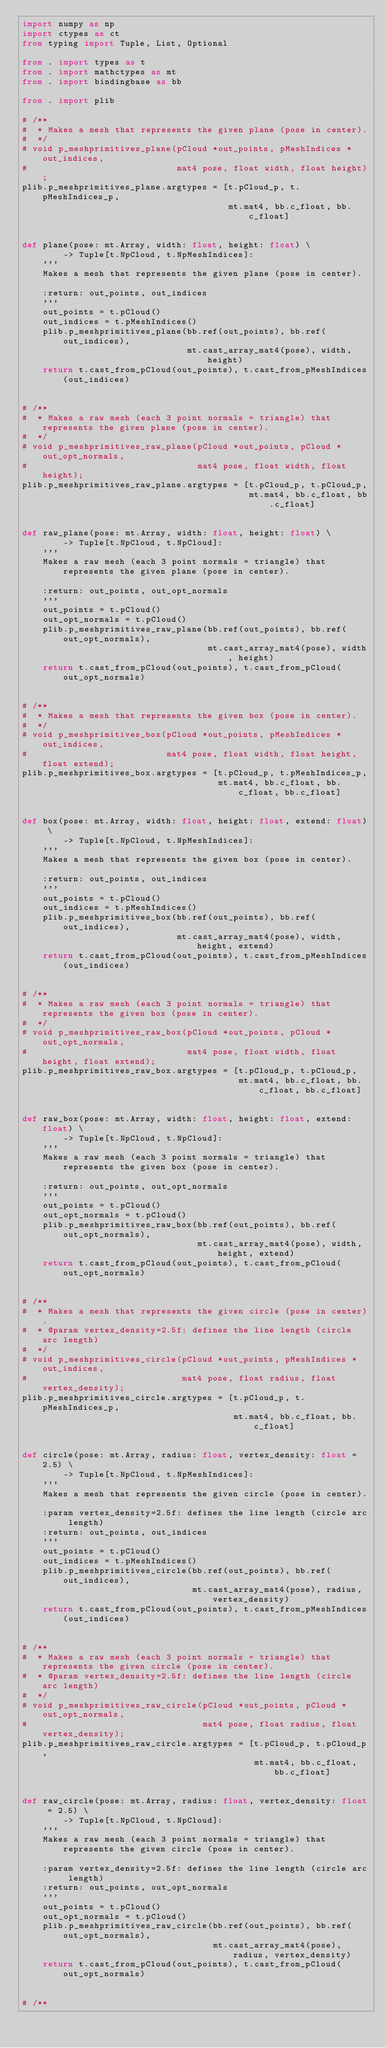<code> <loc_0><loc_0><loc_500><loc_500><_Python_>import numpy as np
import ctypes as ct
from typing import Tuple, List, Optional

from . import types as t
from . import mathctypes as mt
from . import bindingbase as bb

from . import plib

# /**
#  * Makes a mesh that represents the given plane (pose in center).
#  */
# void p_meshprimitives_plane(pCloud *out_points, pMeshIndices *out_indices,
#                             mat4 pose, float width, float height);
plib.p_meshprimitives_plane.argtypes = [t.pCloud_p, t.pMeshIndices_p,
                                        mt.mat4, bb.c_float, bb.c_float]


def plane(pose: mt.Array, width: float, height: float) \
        -> Tuple[t.NpCloud, t.NpMeshIndices]:
    '''
    Makes a mesh that represents the given plane (pose in center).

    :return: out_points, out_indices
    '''
    out_points = t.pCloud()
    out_indices = t.pMeshIndices()
    plib.p_meshprimitives_plane(bb.ref(out_points), bb.ref(out_indices),
                                mt.cast_array_mat4(pose), width, height)
    return t.cast_from_pCloud(out_points), t.cast_from_pMeshIndices(out_indices)


# /**
#  * Makes a raw mesh (each 3 point normals = triangle) that represents the given plane (pose in center).
#  */
# void p_meshprimitives_raw_plane(pCloud *out_points, pCloud *out_opt_normals,
#                                 mat4 pose, float width, float height);
plib.p_meshprimitives_raw_plane.argtypes = [t.pCloud_p, t.pCloud_p,
                                            mt.mat4, bb.c_float, bb.c_float]


def raw_plane(pose: mt.Array, width: float, height: float) \
        -> Tuple[t.NpCloud, t.NpCloud]:
    '''
    Makes a raw mesh (each 3 point normals = triangle) that represents the given plane (pose in center).

    :return: out_points, out_opt_normals
    '''
    out_points = t.pCloud()
    out_opt_normals = t.pCloud()
    plib.p_meshprimitives_raw_plane(bb.ref(out_points), bb.ref(out_opt_normals),
                                    mt.cast_array_mat4(pose), width, height)
    return t.cast_from_pCloud(out_points), t.cast_from_pCloud(out_opt_normals)


# /**
#  * Makes a mesh that represents the given box (pose in center).
#  */
# void p_meshprimitives_box(pCloud *out_points, pMeshIndices *out_indices,
#                           mat4 pose, float width, float height, float extend);
plib.p_meshprimitives_box.argtypes = [t.pCloud_p, t.pMeshIndices_p,
                                      mt.mat4, bb.c_float, bb.c_float, bb.c_float]


def box(pose: mt.Array, width: float, height: float, extend: float) \
        -> Tuple[t.NpCloud, t.NpMeshIndices]:
    '''
    Makes a mesh that represents the given box (pose in center).

    :return: out_points, out_indices
    '''
    out_points = t.pCloud()
    out_indices = t.pMeshIndices()
    plib.p_meshprimitives_box(bb.ref(out_points), bb.ref(out_indices),
                              mt.cast_array_mat4(pose), width, height, extend)
    return t.cast_from_pCloud(out_points), t.cast_from_pMeshIndices(out_indices)


# /**
#  * Makes a raw mesh (each 3 point normals = triangle) that represents the given box (pose in center).
#  */
# void p_meshprimitives_raw_box(pCloud *out_points, pCloud *out_opt_normals,
#                               mat4 pose, float width, float height, float extend);
plib.p_meshprimitives_raw_box.argtypes = [t.pCloud_p, t.pCloud_p,
                                          mt.mat4, bb.c_float, bb.c_float, bb.c_float]


def raw_box(pose: mt.Array, width: float, height: float, extend: float) \
        -> Tuple[t.NpCloud, t.NpCloud]:
    '''
    Makes a raw mesh (each 3 point normals = triangle) that represents the given box (pose in center).

    :return: out_points, out_opt_normals
    '''
    out_points = t.pCloud()
    out_opt_normals = t.pCloud()
    plib.p_meshprimitives_raw_box(bb.ref(out_points), bb.ref(out_opt_normals),
                                  mt.cast_array_mat4(pose), width, height, extend)
    return t.cast_from_pCloud(out_points), t.cast_from_pCloud(out_opt_normals)


# /**
#  * Makes a mesh that represents the given circle (pose in center).
#  * @param vertex_density=2.5f: defines the line length (circle arc length)
#  */
# void p_meshprimitives_circle(pCloud *out_points, pMeshIndices *out_indices,
#                              mat4 pose, float radius, float vertex_density);
plib.p_meshprimitives_circle.argtypes = [t.pCloud_p, t.pMeshIndices_p,
                                         mt.mat4, bb.c_float, bb.c_float]


def circle(pose: mt.Array, radius: float, vertex_density: float = 2.5) \
        -> Tuple[t.NpCloud, t.NpMeshIndices]:
    '''
    Makes a mesh that represents the given circle (pose in center).

    :param vertex_density=2.5f: defines the line length (circle arc length)
    :return: out_points, out_indices
    '''
    out_points = t.pCloud()
    out_indices = t.pMeshIndices()
    plib.p_meshprimitives_circle(bb.ref(out_points), bb.ref(out_indices),
                                 mt.cast_array_mat4(pose), radius, vertex_density)
    return t.cast_from_pCloud(out_points), t.cast_from_pMeshIndices(out_indices)


# /**
#  * Makes a raw mesh (each 3 point normals = triangle) that represents the given circle (pose in center).
#  * @param vertex_density=2.5f: defines the line length (circle arc length)
#  */
# void p_meshprimitives_raw_circle(pCloud *out_points, pCloud *out_opt_normals,
#                                  mat4 pose, float radius, float vertex_density);
plib.p_meshprimitives_raw_circle.argtypes = [t.pCloud_p, t.pCloud_p,
                                             mt.mat4, bb.c_float, bb.c_float]


def raw_circle(pose: mt.Array, radius: float, vertex_density: float = 2.5) \
        -> Tuple[t.NpCloud, t.NpCloud]:
    '''
    Makes a raw mesh (each 3 point normals = triangle) that represents the given circle (pose in center).

    :param vertex_density=2.5f: defines the line length (circle arc length)
    :return: out_points, out_opt_normals
    '''
    out_points = t.pCloud()
    out_opt_normals = t.pCloud()
    plib.p_meshprimitives_raw_circle(bb.ref(out_points), bb.ref(out_opt_normals),
                                     mt.cast_array_mat4(pose), radius, vertex_density)
    return t.cast_from_pCloud(out_points), t.cast_from_pCloud(out_opt_normals)


# /**</code> 